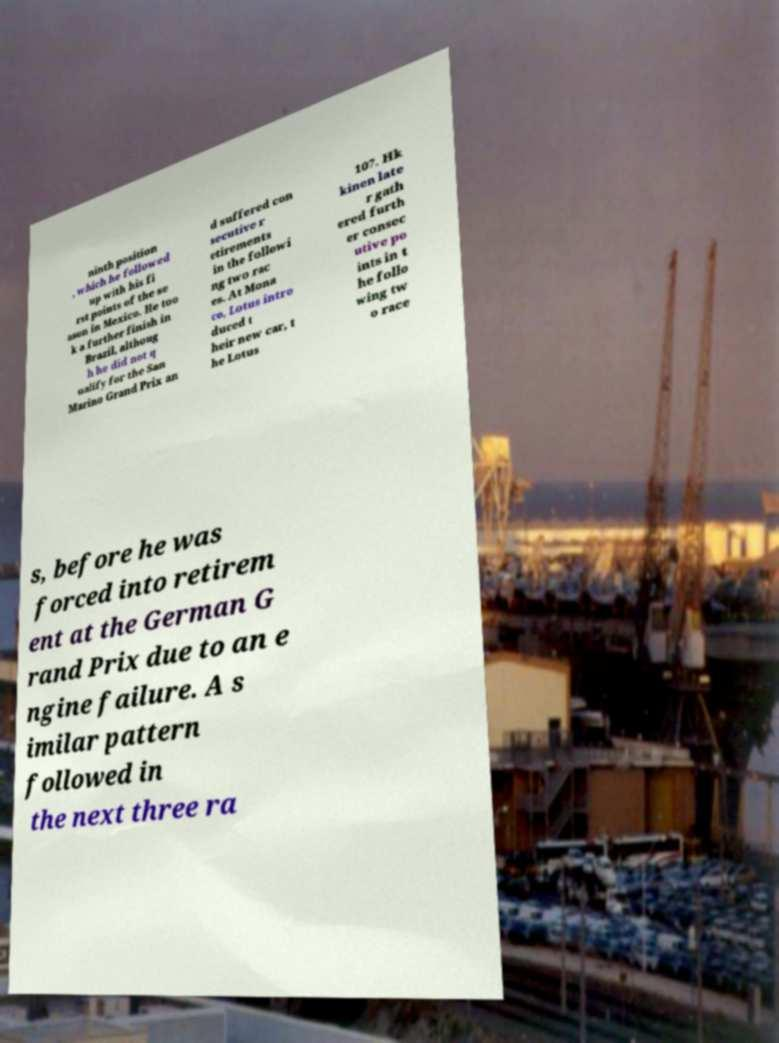What messages or text are displayed in this image? I need them in a readable, typed format. ninth position , which he followed up with his fi rst points of the se ason in Mexico. He too k a further finish in Brazil, althoug h he did not q ualify for the San Marino Grand Prix an d suffered con secutive r etirements in the followi ng two rac es. At Mona co, Lotus intro duced t heir new car, t he Lotus 107. Hk kinen late r gath ered furth er consec utive po ints in t he follo wing tw o race s, before he was forced into retirem ent at the German G rand Prix due to an e ngine failure. A s imilar pattern followed in the next three ra 